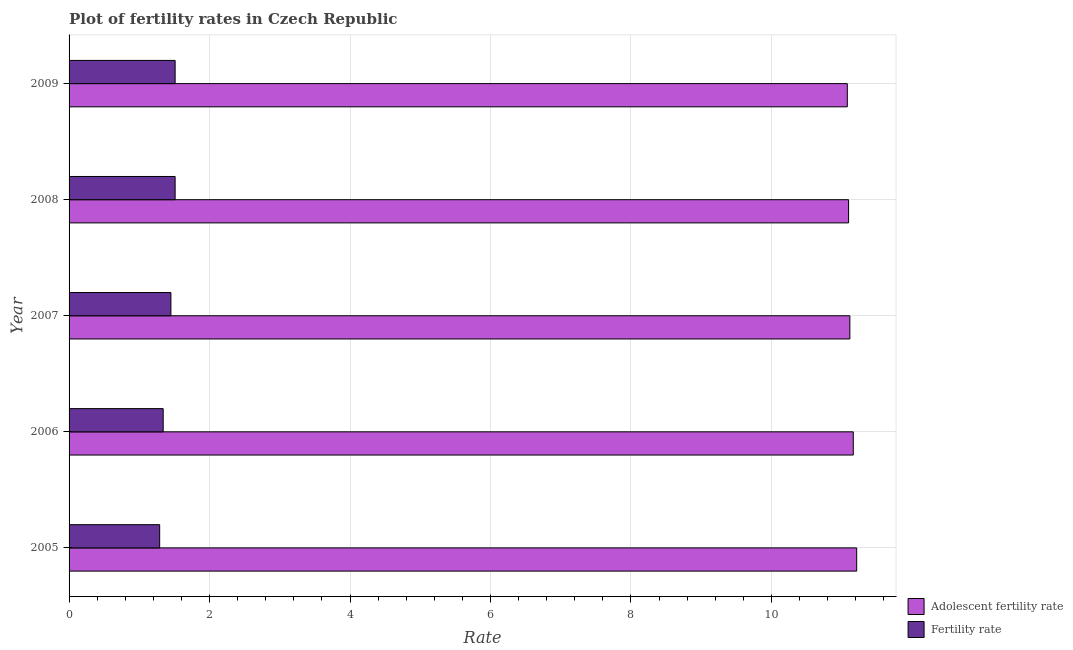How many groups of bars are there?
Your response must be concise. 5. Are the number of bars per tick equal to the number of legend labels?
Your answer should be very brief. Yes. Are the number of bars on each tick of the Y-axis equal?
Provide a short and direct response. Yes. How many bars are there on the 1st tick from the top?
Provide a short and direct response. 2. How many bars are there on the 4th tick from the bottom?
Offer a terse response. 2. What is the adolescent fertility rate in 2008?
Ensure brevity in your answer.  11.1. Across all years, what is the maximum fertility rate?
Your answer should be very brief. 1.51. Across all years, what is the minimum adolescent fertility rate?
Your answer should be compact. 11.08. What is the total adolescent fertility rate in the graph?
Offer a terse response. 55.68. What is the difference between the fertility rate in 2005 and that in 2008?
Offer a terse response. -0.22. What is the difference between the fertility rate in 2006 and the adolescent fertility rate in 2008?
Give a very brief answer. -9.76. What is the average adolescent fertility rate per year?
Provide a succinct answer. 11.13. In the year 2008, what is the difference between the fertility rate and adolescent fertility rate?
Provide a short and direct response. -9.59. What is the difference between the highest and the second highest adolescent fertility rate?
Your response must be concise. 0.05. What is the difference between the highest and the lowest fertility rate?
Keep it short and to the point. 0.22. In how many years, is the fertility rate greater than the average fertility rate taken over all years?
Offer a terse response. 3. Is the sum of the adolescent fertility rate in 2006 and 2007 greater than the maximum fertility rate across all years?
Provide a succinct answer. Yes. What does the 2nd bar from the top in 2005 represents?
Your answer should be compact. Adolescent fertility rate. What does the 1st bar from the bottom in 2005 represents?
Provide a succinct answer. Adolescent fertility rate. Are all the bars in the graph horizontal?
Offer a terse response. Yes. How many years are there in the graph?
Your answer should be compact. 5. Where does the legend appear in the graph?
Your answer should be compact. Bottom right. What is the title of the graph?
Your response must be concise. Plot of fertility rates in Czech Republic. Does "Girls" appear as one of the legend labels in the graph?
Give a very brief answer. No. What is the label or title of the X-axis?
Your answer should be compact. Rate. What is the Rate in Adolescent fertility rate in 2005?
Offer a very short reply. 11.21. What is the Rate in Fertility rate in 2005?
Provide a short and direct response. 1.29. What is the Rate of Adolescent fertility rate in 2006?
Your answer should be compact. 11.17. What is the Rate of Fertility rate in 2006?
Offer a terse response. 1.34. What is the Rate of Adolescent fertility rate in 2007?
Your answer should be compact. 11.12. What is the Rate of Fertility rate in 2007?
Your answer should be very brief. 1.45. What is the Rate in Adolescent fertility rate in 2008?
Offer a terse response. 11.1. What is the Rate of Fertility rate in 2008?
Your answer should be very brief. 1.51. What is the Rate in Adolescent fertility rate in 2009?
Your answer should be very brief. 11.08. What is the Rate in Fertility rate in 2009?
Provide a short and direct response. 1.51. Across all years, what is the maximum Rate of Adolescent fertility rate?
Offer a very short reply. 11.21. Across all years, what is the maximum Rate in Fertility rate?
Provide a succinct answer. 1.51. Across all years, what is the minimum Rate in Adolescent fertility rate?
Provide a short and direct response. 11.08. Across all years, what is the minimum Rate of Fertility rate?
Make the answer very short. 1.29. What is the total Rate of Adolescent fertility rate in the graph?
Your answer should be very brief. 55.68. What is the difference between the Rate in Adolescent fertility rate in 2005 and that in 2006?
Provide a short and direct response. 0.05. What is the difference between the Rate in Fertility rate in 2005 and that in 2006?
Offer a very short reply. -0.05. What is the difference between the Rate in Adolescent fertility rate in 2005 and that in 2007?
Offer a terse response. 0.1. What is the difference between the Rate in Fertility rate in 2005 and that in 2007?
Give a very brief answer. -0.16. What is the difference between the Rate in Adolescent fertility rate in 2005 and that in 2008?
Your response must be concise. 0.12. What is the difference between the Rate in Fertility rate in 2005 and that in 2008?
Give a very brief answer. -0.22. What is the difference between the Rate of Adolescent fertility rate in 2005 and that in 2009?
Make the answer very short. 0.13. What is the difference between the Rate of Fertility rate in 2005 and that in 2009?
Keep it short and to the point. -0.22. What is the difference between the Rate of Adolescent fertility rate in 2006 and that in 2007?
Ensure brevity in your answer.  0.05. What is the difference between the Rate of Fertility rate in 2006 and that in 2007?
Offer a terse response. -0.11. What is the difference between the Rate in Adolescent fertility rate in 2006 and that in 2008?
Your answer should be very brief. 0.07. What is the difference between the Rate in Fertility rate in 2006 and that in 2008?
Ensure brevity in your answer.  -0.17. What is the difference between the Rate of Adolescent fertility rate in 2006 and that in 2009?
Keep it short and to the point. 0.09. What is the difference between the Rate in Fertility rate in 2006 and that in 2009?
Ensure brevity in your answer.  -0.17. What is the difference between the Rate of Adolescent fertility rate in 2007 and that in 2008?
Your answer should be very brief. 0.02. What is the difference between the Rate in Fertility rate in 2007 and that in 2008?
Provide a succinct answer. -0.06. What is the difference between the Rate in Adolescent fertility rate in 2007 and that in 2009?
Provide a succinct answer. 0.04. What is the difference between the Rate in Fertility rate in 2007 and that in 2009?
Your answer should be very brief. -0.06. What is the difference between the Rate of Adolescent fertility rate in 2008 and that in 2009?
Provide a succinct answer. 0.02. What is the difference between the Rate in Adolescent fertility rate in 2005 and the Rate in Fertility rate in 2006?
Provide a succinct answer. 9.87. What is the difference between the Rate of Adolescent fertility rate in 2005 and the Rate of Fertility rate in 2007?
Your answer should be very brief. 9.76. What is the difference between the Rate in Adolescent fertility rate in 2005 and the Rate in Fertility rate in 2008?
Make the answer very short. 9.7. What is the difference between the Rate of Adolescent fertility rate in 2005 and the Rate of Fertility rate in 2009?
Provide a succinct answer. 9.7. What is the difference between the Rate in Adolescent fertility rate in 2006 and the Rate in Fertility rate in 2007?
Provide a short and direct response. 9.72. What is the difference between the Rate of Adolescent fertility rate in 2006 and the Rate of Fertility rate in 2008?
Keep it short and to the point. 9.66. What is the difference between the Rate in Adolescent fertility rate in 2006 and the Rate in Fertility rate in 2009?
Ensure brevity in your answer.  9.66. What is the difference between the Rate of Adolescent fertility rate in 2007 and the Rate of Fertility rate in 2008?
Your answer should be very brief. 9.61. What is the difference between the Rate of Adolescent fertility rate in 2007 and the Rate of Fertility rate in 2009?
Your answer should be compact. 9.61. What is the difference between the Rate in Adolescent fertility rate in 2008 and the Rate in Fertility rate in 2009?
Make the answer very short. 9.59. What is the average Rate in Adolescent fertility rate per year?
Make the answer very short. 11.14. What is the average Rate in Fertility rate per year?
Your response must be concise. 1.42. In the year 2005, what is the difference between the Rate in Adolescent fertility rate and Rate in Fertility rate?
Make the answer very short. 9.92. In the year 2006, what is the difference between the Rate in Adolescent fertility rate and Rate in Fertility rate?
Your answer should be compact. 9.83. In the year 2007, what is the difference between the Rate of Adolescent fertility rate and Rate of Fertility rate?
Your answer should be very brief. 9.67. In the year 2008, what is the difference between the Rate in Adolescent fertility rate and Rate in Fertility rate?
Offer a very short reply. 9.59. In the year 2009, what is the difference between the Rate of Adolescent fertility rate and Rate of Fertility rate?
Provide a succinct answer. 9.57. What is the ratio of the Rate of Adolescent fertility rate in 2005 to that in 2006?
Provide a succinct answer. 1. What is the ratio of the Rate in Fertility rate in 2005 to that in 2006?
Your answer should be compact. 0.96. What is the ratio of the Rate of Adolescent fertility rate in 2005 to that in 2007?
Offer a very short reply. 1.01. What is the ratio of the Rate in Fertility rate in 2005 to that in 2007?
Provide a succinct answer. 0.89. What is the ratio of the Rate of Adolescent fertility rate in 2005 to that in 2008?
Your answer should be very brief. 1.01. What is the ratio of the Rate of Fertility rate in 2005 to that in 2008?
Provide a succinct answer. 0.85. What is the ratio of the Rate of Adolescent fertility rate in 2005 to that in 2009?
Your answer should be very brief. 1.01. What is the ratio of the Rate in Fertility rate in 2005 to that in 2009?
Give a very brief answer. 0.85. What is the ratio of the Rate in Fertility rate in 2006 to that in 2007?
Ensure brevity in your answer.  0.92. What is the ratio of the Rate in Adolescent fertility rate in 2006 to that in 2008?
Ensure brevity in your answer.  1.01. What is the ratio of the Rate of Fertility rate in 2006 to that in 2008?
Offer a very short reply. 0.89. What is the ratio of the Rate of Adolescent fertility rate in 2006 to that in 2009?
Offer a very short reply. 1.01. What is the ratio of the Rate of Fertility rate in 2006 to that in 2009?
Keep it short and to the point. 0.89. What is the ratio of the Rate of Fertility rate in 2007 to that in 2008?
Keep it short and to the point. 0.96. What is the ratio of the Rate of Fertility rate in 2007 to that in 2009?
Your answer should be compact. 0.96. What is the ratio of the Rate of Adolescent fertility rate in 2008 to that in 2009?
Offer a very short reply. 1. What is the ratio of the Rate of Fertility rate in 2008 to that in 2009?
Make the answer very short. 1. What is the difference between the highest and the second highest Rate in Adolescent fertility rate?
Your answer should be very brief. 0.05. What is the difference between the highest and the second highest Rate in Fertility rate?
Your answer should be very brief. 0. What is the difference between the highest and the lowest Rate of Adolescent fertility rate?
Ensure brevity in your answer.  0.13. What is the difference between the highest and the lowest Rate in Fertility rate?
Provide a short and direct response. 0.22. 